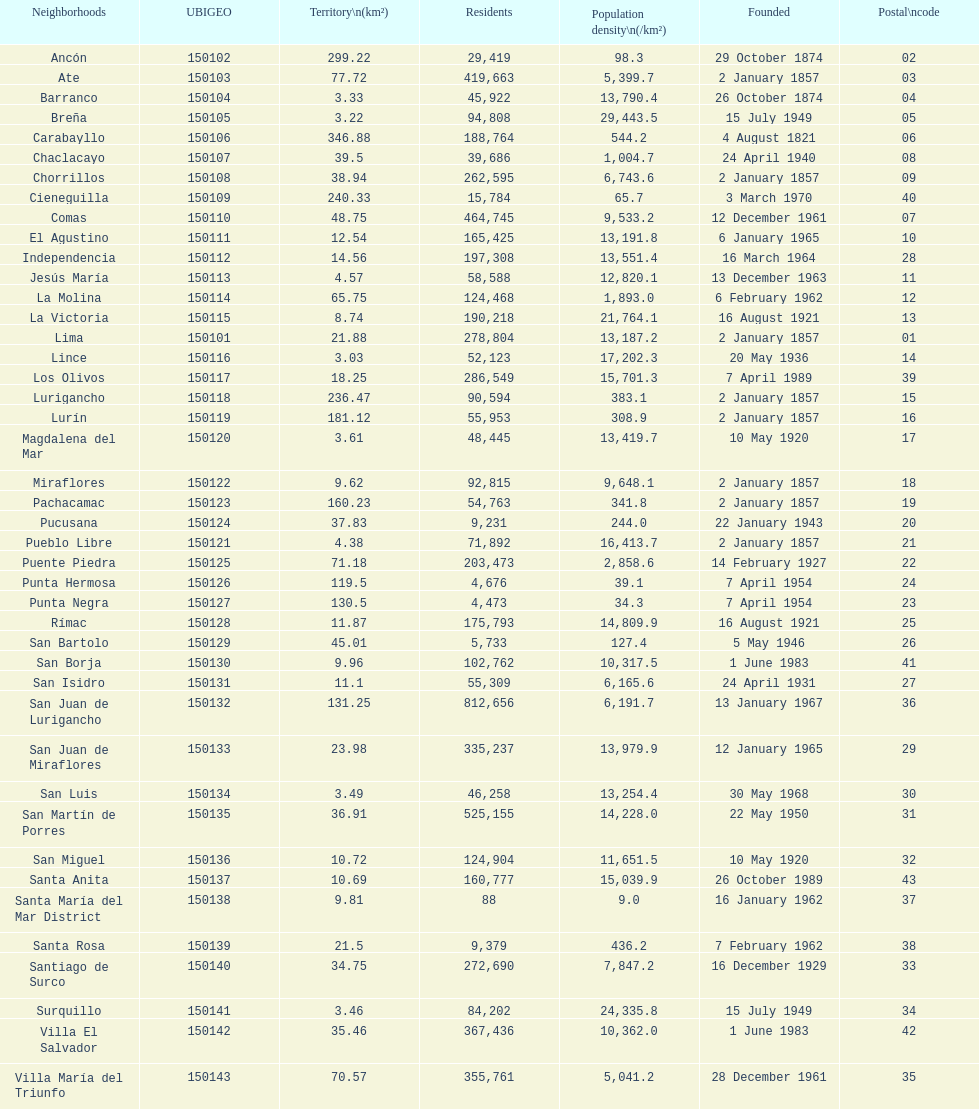What district has the least amount of population? Santa María del Mar District. 